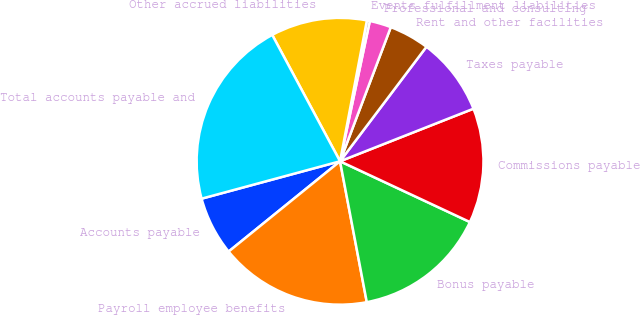<chart> <loc_0><loc_0><loc_500><loc_500><pie_chart><fcel>Accounts payable<fcel>Payroll employee benefits<fcel>Bonus payable<fcel>Commissions payable<fcel>Taxes payable<fcel>Rent and other facilities<fcel>Professional and consulting<fcel>Events fulfillment liabilities<fcel>Other accrued liabilities<fcel>Total accounts payable and<nl><fcel>6.64%<fcel>17.15%<fcel>15.05%<fcel>12.94%<fcel>8.74%<fcel>4.53%<fcel>2.43%<fcel>0.33%<fcel>10.84%<fcel>21.36%<nl></chart> 